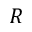<formula> <loc_0><loc_0><loc_500><loc_500>R</formula> 